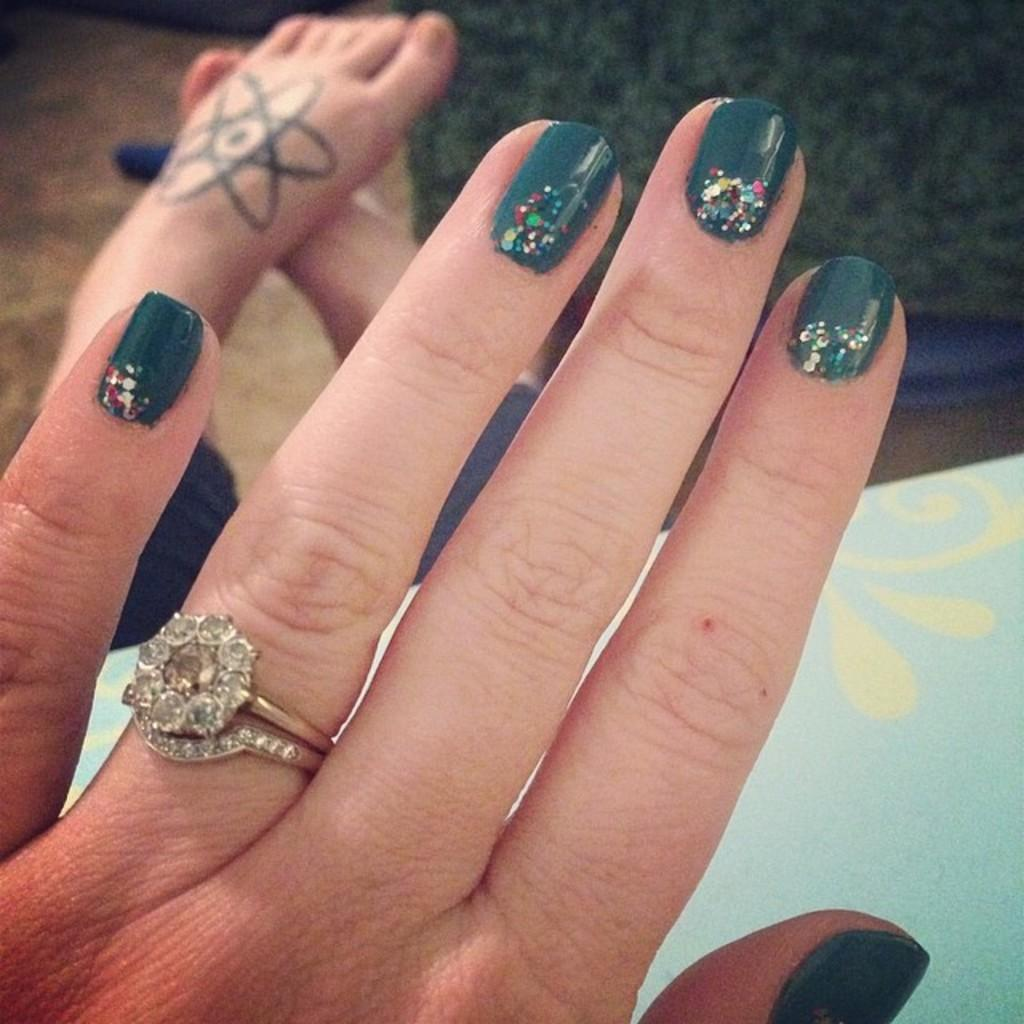What is present in the image? There is a person in the image. What parts of the person's body can be seen? The person's hands and legs are visible in the image. What type of tray is the person holding in the image? There is no tray present in the image. 